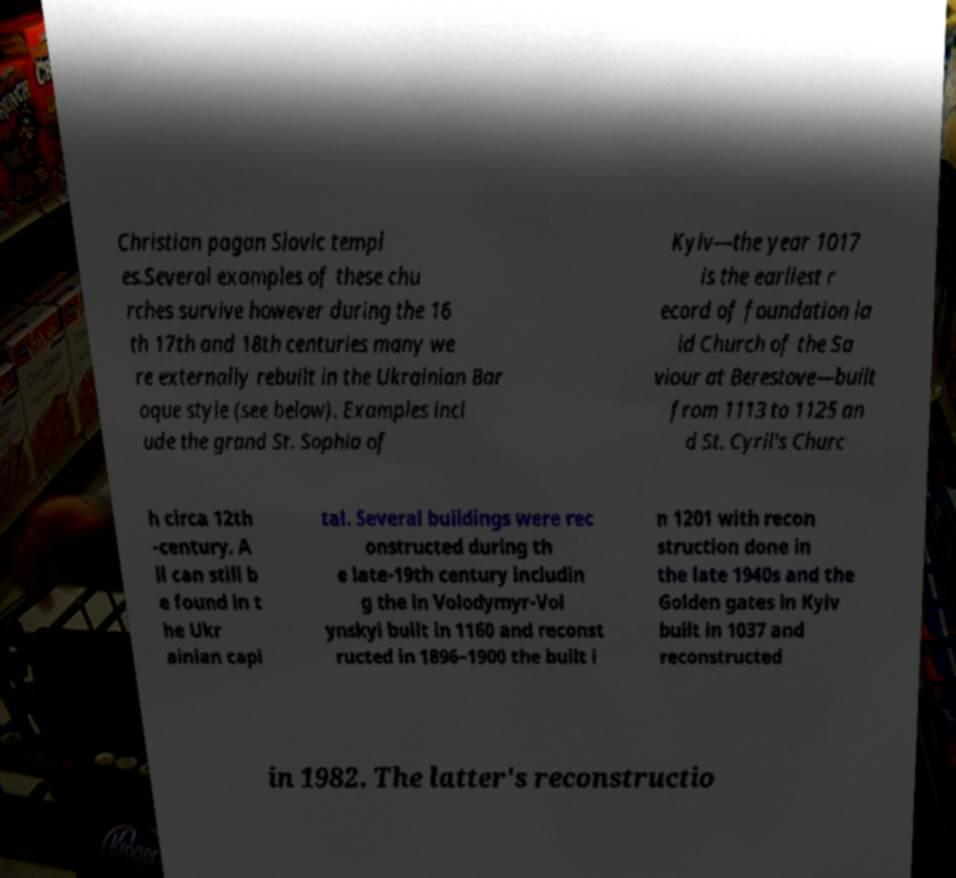Could you extract and type out the text from this image? Christian pagan Slavic templ es.Several examples of these chu rches survive however during the 16 th 17th and 18th centuries many we re externally rebuilt in the Ukrainian Bar oque style (see below). Examples incl ude the grand St. Sophia of Kyiv—the year 1017 is the earliest r ecord of foundation la id Church of the Sa viour at Berestove—built from 1113 to 1125 an d St. Cyril's Churc h circa 12th -century. A ll can still b e found in t he Ukr ainian capi tal. Several buildings were rec onstructed during th e late-19th century includin g the in Volodymyr-Vol ynskyi built in 1160 and reconst ructed in 1896–1900 the built i n 1201 with recon struction done in the late 1940s and the Golden gates in Kyiv built in 1037 and reconstructed in 1982. The latter's reconstructio 